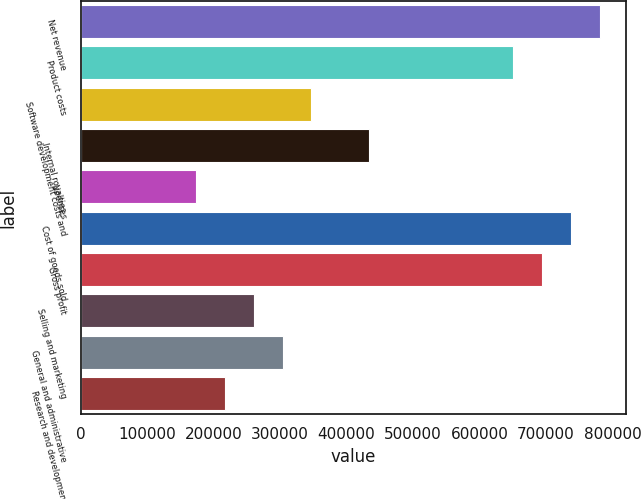Convert chart. <chart><loc_0><loc_0><loc_500><loc_500><bar_chart><fcel>Net revenue<fcel>Product costs<fcel>Software development costs and<fcel>Internal royalties<fcel>Licenses<fcel>Cost of goods sold<fcel>Gross profit<fcel>Selling and marketing<fcel>General and administrative<fcel>Research and development<nl><fcel>780904<fcel>650754<fcel>347069<fcel>433836<fcel>173535<fcel>737521<fcel>694137<fcel>260302<fcel>303685<fcel>216918<nl></chart> 